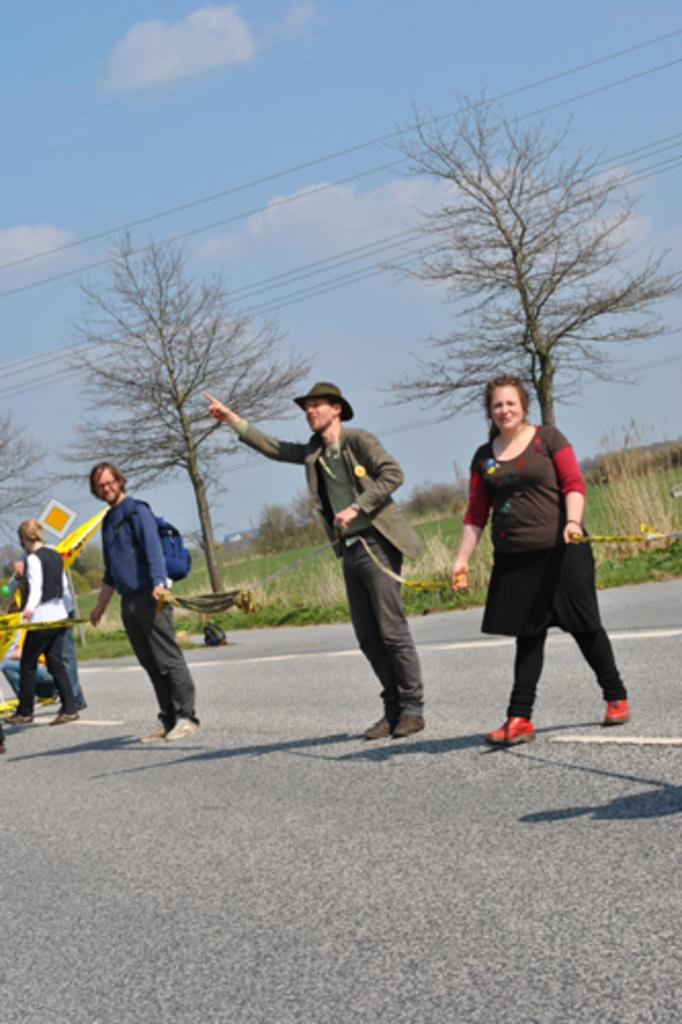What can be seen in the image? There are people standing in the image. What is visible in the background of the image? There are trees and grass in the background of the image. What is visible at the top of the image? The sky is visible at the top of the image. What object is located in the middle of the image? There is a board in the middle of the image. How many windows can be seen on the people's legs in the image? There are no windows visible on the people's legs in the image, as windows are not a part of the human body. 